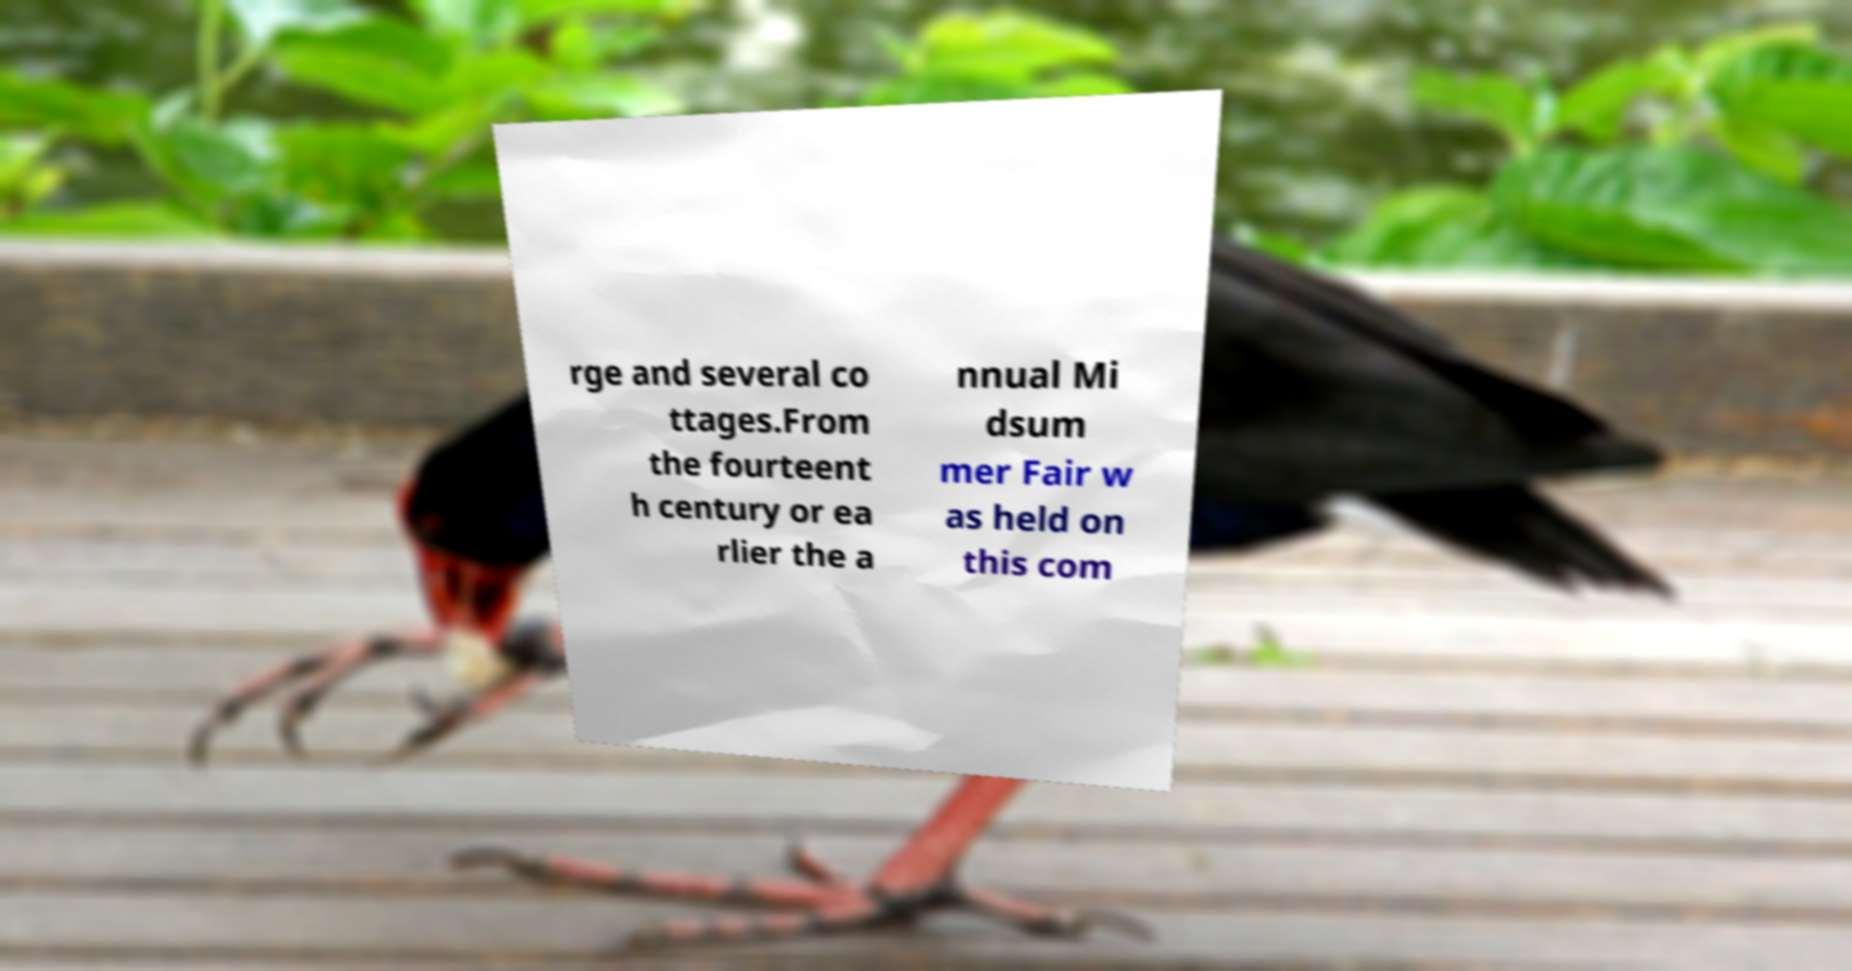Could you assist in decoding the text presented in this image and type it out clearly? rge and several co ttages.From the fourteent h century or ea rlier the a nnual Mi dsum mer Fair w as held on this com 